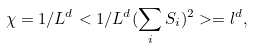Convert formula to latex. <formula><loc_0><loc_0><loc_500><loc_500>\chi = 1 / L ^ { d } < 1 / L ^ { d } ( \sum _ { i } S _ { i } ) ^ { 2 } > = l ^ { d } ,</formula> 